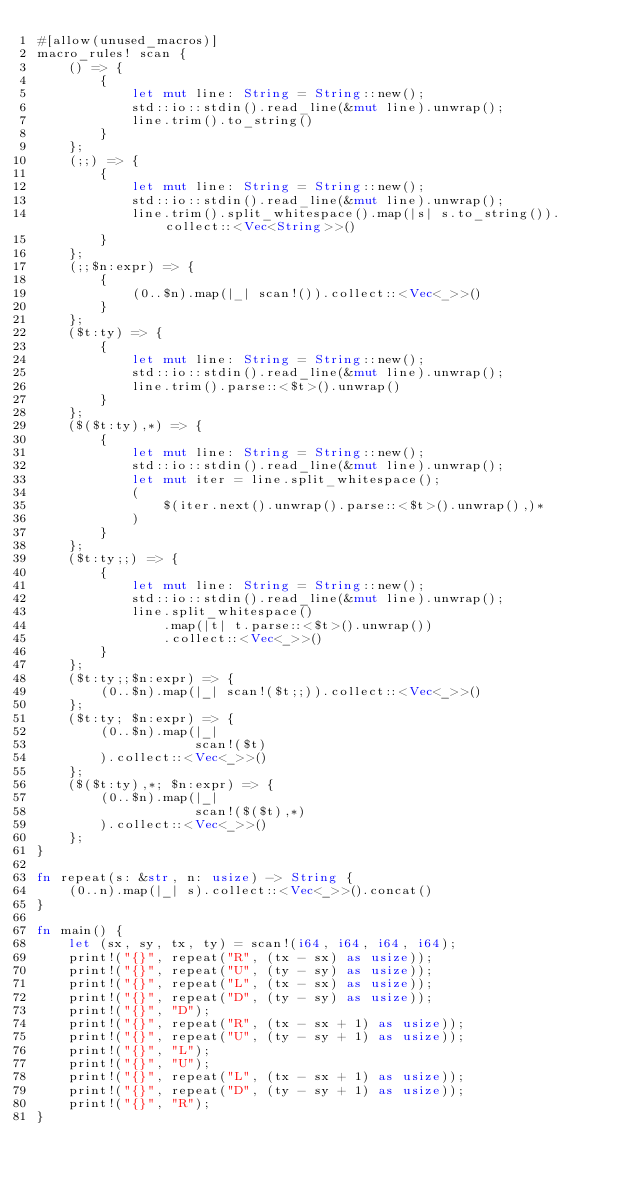<code> <loc_0><loc_0><loc_500><loc_500><_Rust_>#[allow(unused_macros)]
macro_rules! scan {
    () => {
        {
            let mut line: String = String::new();
            std::io::stdin().read_line(&mut line).unwrap();
            line.trim().to_string()
        }
    };
    (;;) => {
        {
            let mut line: String = String::new();
            std::io::stdin().read_line(&mut line).unwrap();
            line.trim().split_whitespace().map(|s| s.to_string()).collect::<Vec<String>>()
        }
    };
    (;;$n:expr) => {
        {
            (0..$n).map(|_| scan!()).collect::<Vec<_>>()
        }
    };
    ($t:ty) => {
        {
            let mut line: String = String::new();
            std::io::stdin().read_line(&mut line).unwrap();
            line.trim().parse::<$t>().unwrap()
        }
    };
    ($($t:ty),*) => {
        {
            let mut line: String = String::new();
            std::io::stdin().read_line(&mut line).unwrap();
            let mut iter = line.split_whitespace();
            (
                $(iter.next().unwrap().parse::<$t>().unwrap(),)*
            )
        }
    };
    ($t:ty;;) => {
        {
            let mut line: String = String::new();
            std::io::stdin().read_line(&mut line).unwrap();
            line.split_whitespace()
                .map(|t| t.parse::<$t>().unwrap())
                .collect::<Vec<_>>()
        }
    };
    ($t:ty;;$n:expr) => {
        (0..$n).map(|_| scan!($t;;)).collect::<Vec<_>>()
    };
    ($t:ty; $n:expr) => {
        (0..$n).map(|_|
                    scan!($t)
        ).collect::<Vec<_>>()
    };
    ($($t:ty),*; $n:expr) => {
        (0..$n).map(|_|
                    scan!($($t),*)
        ).collect::<Vec<_>>()
    };
}

fn repeat(s: &str, n: usize) -> String {
    (0..n).map(|_| s).collect::<Vec<_>>().concat()
}

fn main() {
    let (sx, sy, tx, ty) = scan!(i64, i64, i64, i64);
    print!("{}", repeat("R", (tx - sx) as usize));
    print!("{}", repeat("U", (ty - sy) as usize));
    print!("{}", repeat("L", (tx - sx) as usize));
    print!("{}", repeat("D", (ty - sy) as usize));
    print!("{}", "D");
    print!("{}", repeat("R", (tx - sx + 1) as usize));
    print!("{}", repeat("U", (ty - sy + 1) as usize));
    print!("{}", "L");
    print!("{}", "U");
    print!("{}", repeat("L", (tx - sx + 1) as usize));
    print!("{}", repeat("D", (ty - sy + 1) as usize));
    print!("{}", "R");
}
</code> 